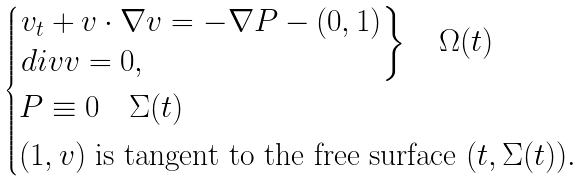Convert formula to latex. <formula><loc_0><loc_0><loc_500><loc_500>\begin{cases} \begin{rcases} v _ { t } + v \cdot \nabla v = - \nabla P - ( 0 , 1 ) \\ d i v v = 0 , \\ \end{rcases} \quad \Omega ( t ) \\ P \equiv 0 \quad \Sigma ( t ) \\ ( 1 , v ) \text { is tangent to the free surface } ( t , \Sigma ( t ) ) . \end{cases}</formula> 